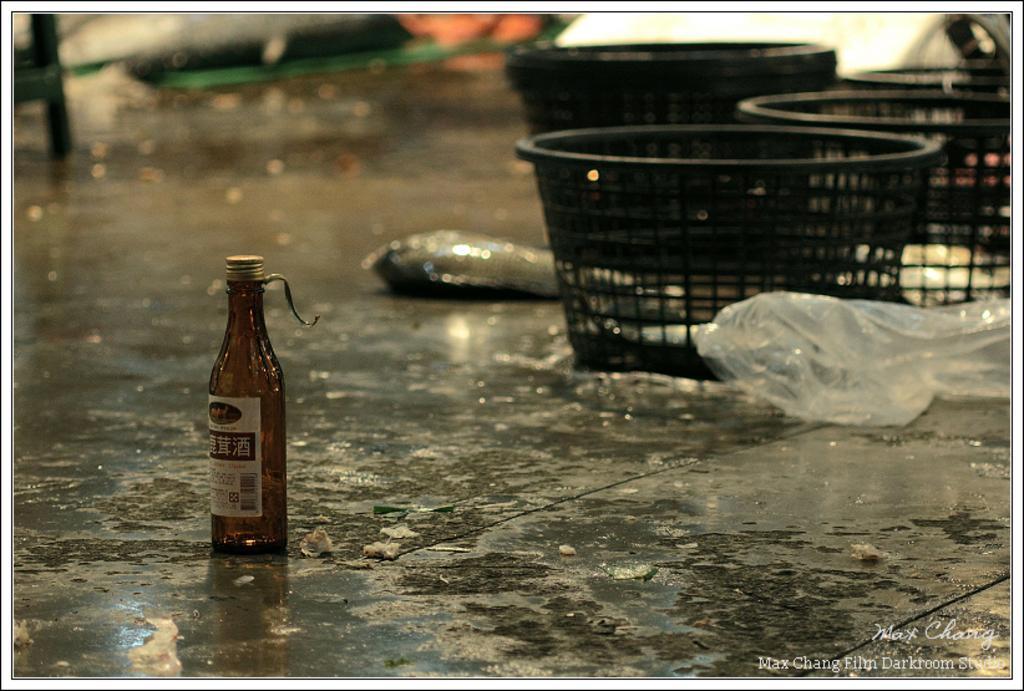Please provide a concise description of this image. In this image some plastic bags are there and one bottle is there on land the background is rainy. 